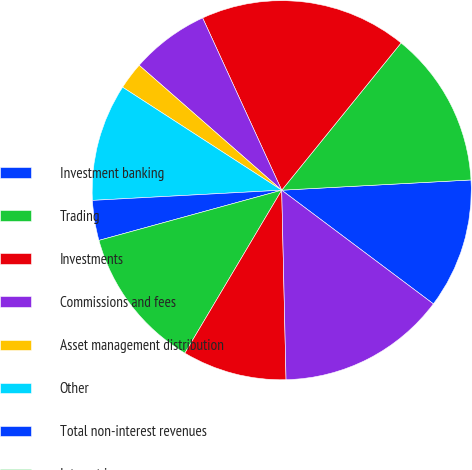Convert chart to OTSL. <chart><loc_0><loc_0><loc_500><loc_500><pie_chart><fcel>Investment banking<fcel>Trading<fcel>Investments<fcel>Commissions and fees<fcel>Asset management distribution<fcel>Other<fcel>Total non-interest revenues<fcel>Interest income<fcel>Interest expense<fcel>Net interest<nl><fcel>11.1%<fcel>13.3%<fcel>17.69%<fcel>6.7%<fcel>2.31%<fcel>10.0%<fcel>3.41%<fcel>12.2%<fcel>8.9%<fcel>14.4%<nl></chart> 